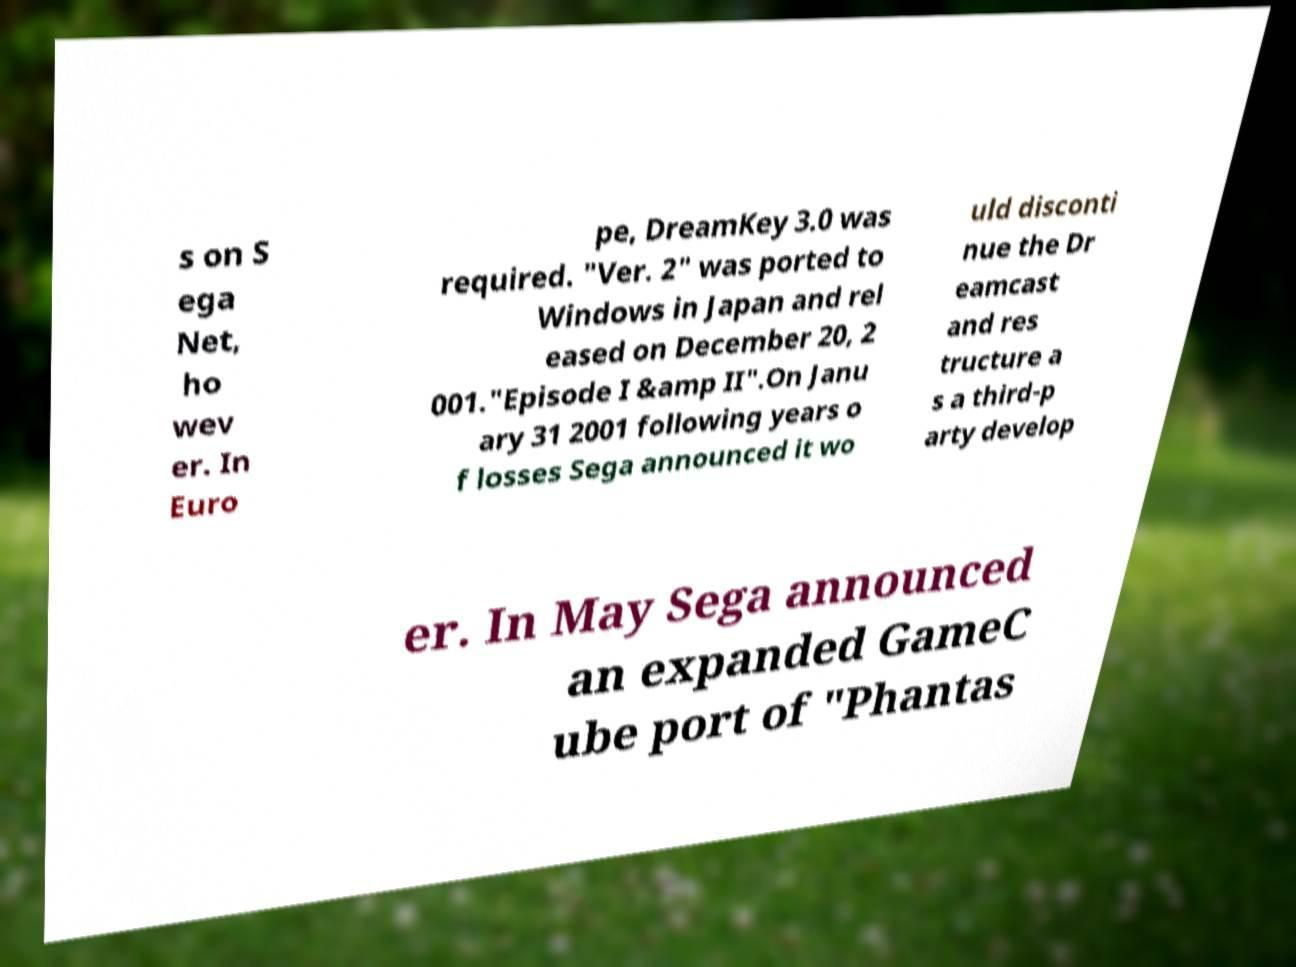Please read and relay the text visible in this image. What does it say? s on S ega Net, ho wev er. In Euro pe, DreamKey 3.0 was required. "Ver. 2" was ported to Windows in Japan and rel eased on December 20, 2 001."Episode I &amp II".On Janu ary 31 2001 following years o f losses Sega announced it wo uld disconti nue the Dr eamcast and res tructure a s a third-p arty develop er. In May Sega announced an expanded GameC ube port of "Phantas 